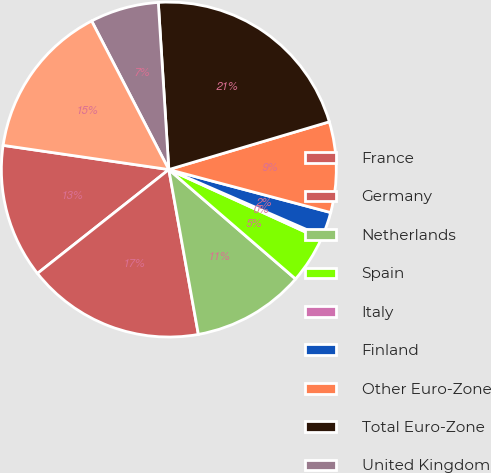<chart> <loc_0><loc_0><loc_500><loc_500><pie_chart><fcel>France<fcel>Germany<fcel>Netherlands<fcel>Spain<fcel>Italy<fcel>Finland<fcel>Other Euro-Zone<fcel>Total Euro-Zone<fcel>United Kingdom<fcel>Other remainder of Europe<nl><fcel>12.95%<fcel>17.17%<fcel>10.84%<fcel>4.51%<fcel>0.29%<fcel>2.4%<fcel>8.73%<fcel>21.39%<fcel>6.62%<fcel>15.06%<nl></chart> 